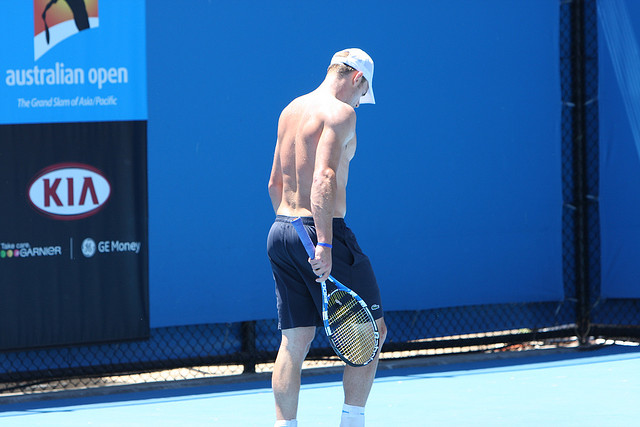Describe a realistic scenario where this tennis player might be getting ready for a tournament in a short response. The tennis player, sweating under the midday sun, practices intensely on the blue court. His coach watches closely, occasionally offering tips to perfect his form. With the Australian Open days away, every rally and serve are crucial. As the practice session concludes, he cools down with stretching exercises, hydrates extensively, and leaves the court focused and determined for the challenges that lie ahead. 